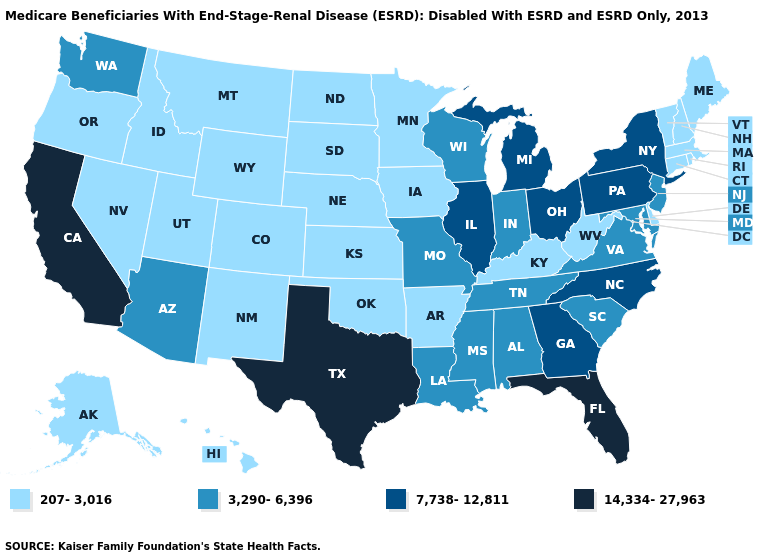Which states have the lowest value in the West?
Give a very brief answer. Alaska, Colorado, Hawaii, Idaho, Montana, Nevada, New Mexico, Oregon, Utah, Wyoming. What is the value of Montana?
Be succinct. 207-3,016. Does the map have missing data?
Write a very short answer. No. Which states hav the highest value in the South?
Concise answer only. Florida, Texas. What is the lowest value in the USA?
Be succinct. 207-3,016. Among the states that border Maryland , does Pennsylvania have the highest value?
Answer briefly. Yes. Does Florida have the highest value in the USA?
Keep it brief. Yes. What is the value of Nevada?
Keep it brief. 207-3,016. Name the states that have a value in the range 207-3,016?
Give a very brief answer. Alaska, Arkansas, Colorado, Connecticut, Delaware, Hawaii, Idaho, Iowa, Kansas, Kentucky, Maine, Massachusetts, Minnesota, Montana, Nebraska, Nevada, New Hampshire, New Mexico, North Dakota, Oklahoma, Oregon, Rhode Island, South Dakota, Utah, Vermont, West Virginia, Wyoming. Does California have the highest value in the USA?
Be succinct. Yes. What is the lowest value in the MidWest?
Write a very short answer. 207-3,016. Does Montana have the highest value in the West?
Concise answer only. No. What is the value of Delaware?
Short answer required. 207-3,016. Among the states that border Florida , does Alabama have the lowest value?
Be succinct. Yes. Name the states that have a value in the range 14,334-27,963?
Short answer required. California, Florida, Texas. 